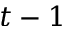Convert formula to latex. <formula><loc_0><loc_0><loc_500><loc_500>t - 1</formula> 